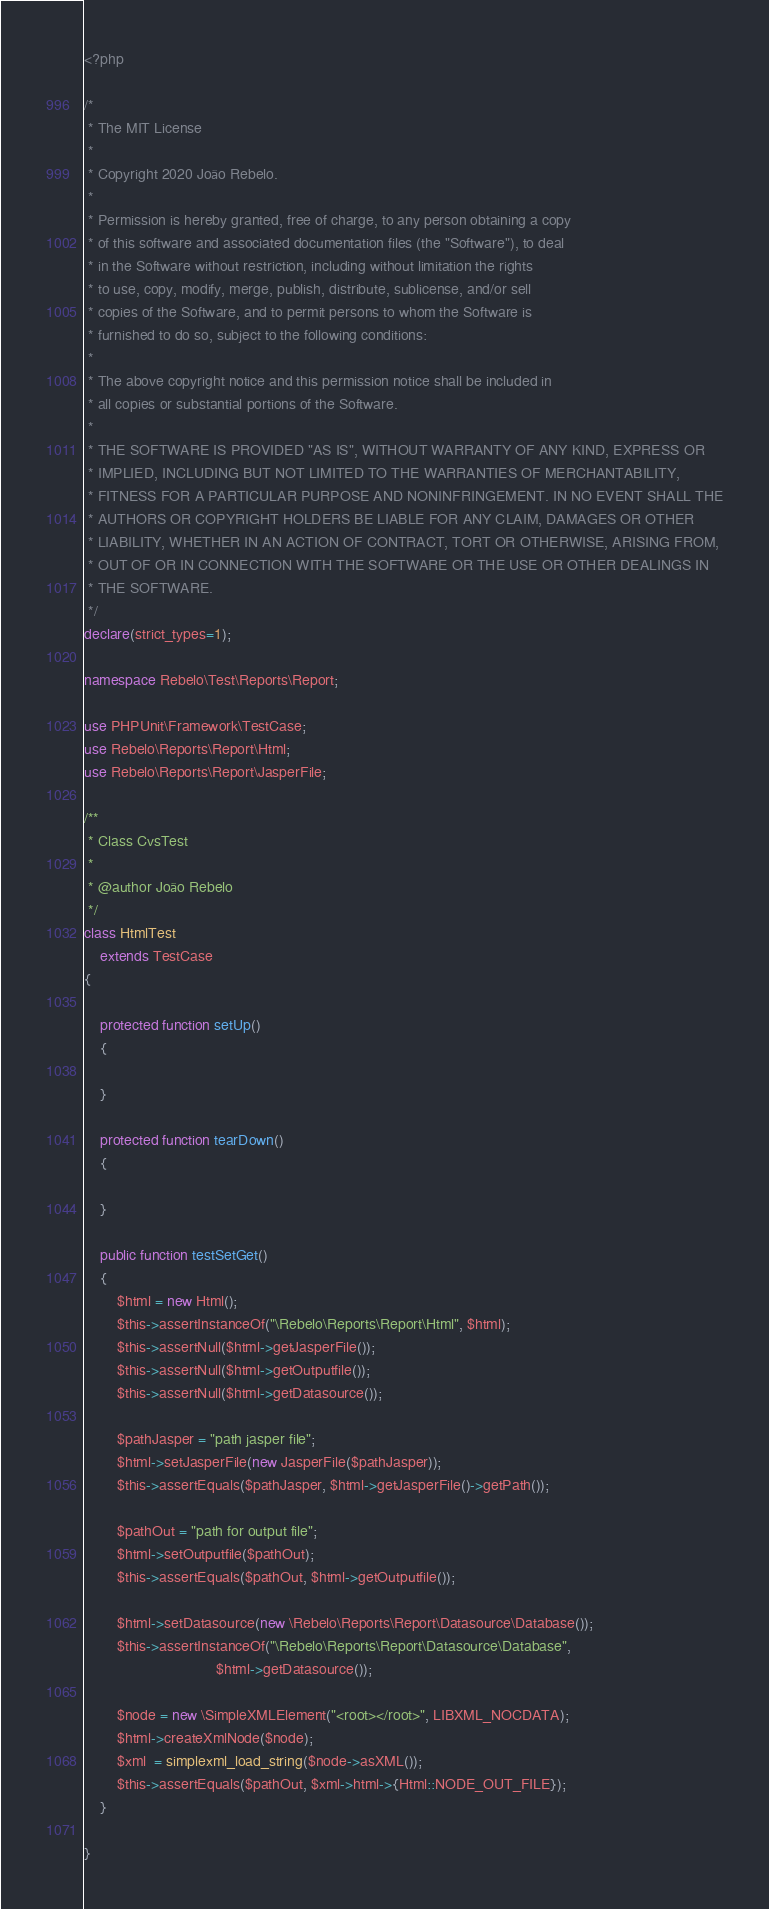<code> <loc_0><loc_0><loc_500><loc_500><_PHP_><?php

/*
 * The MIT License
 *
 * Copyright 2020 João Rebelo.
 *
 * Permission is hereby granted, free of charge, to any person obtaining a copy
 * of this software and associated documentation files (the "Software"), to deal
 * in the Software without restriction, including without limitation the rights
 * to use, copy, modify, merge, publish, distribute, sublicense, and/or sell
 * copies of the Software, and to permit persons to whom the Software is
 * furnished to do so, subject to the following conditions:
 *
 * The above copyright notice and this permission notice shall be included in
 * all copies or substantial portions of the Software.
 *
 * THE SOFTWARE IS PROVIDED "AS IS", WITHOUT WARRANTY OF ANY KIND, EXPRESS OR
 * IMPLIED, INCLUDING BUT NOT LIMITED TO THE WARRANTIES OF MERCHANTABILITY,
 * FITNESS FOR A PARTICULAR PURPOSE AND NONINFRINGEMENT. IN NO EVENT SHALL THE
 * AUTHORS OR COPYRIGHT HOLDERS BE LIABLE FOR ANY CLAIM, DAMAGES OR OTHER
 * LIABILITY, WHETHER IN AN ACTION OF CONTRACT, TORT OR OTHERWISE, ARISING FROM,
 * OUT OF OR IN CONNECTION WITH THE SOFTWARE OR THE USE OR OTHER DEALINGS IN
 * THE SOFTWARE.
 */
declare(strict_types=1);

namespace Rebelo\Test\Reports\Report;

use PHPUnit\Framework\TestCase;
use Rebelo\Reports\Report\Html;
use Rebelo\Reports\Report\JasperFile;

/**
 * Class CvsTest
 *
 * @author João Rebelo
 */
class HtmlTest
    extends TestCase
{

    protected function setUp()
    {

    }

    protected function tearDown()
    {

    }

    public function testSetGet()
    {
        $html = new Html();
        $this->assertInstanceOf("\Rebelo\Reports\Report\Html", $html);
        $this->assertNull($html->getJasperFile());
        $this->assertNull($html->getOutputfile());
        $this->assertNull($html->getDatasource());

        $pathJasper = "path jasper file";
        $html->setJasperFile(new JasperFile($pathJasper));
        $this->assertEquals($pathJasper, $html->getJasperFile()->getPath());

        $pathOut = "path for output file";
        $html->setOutputfile($pathOut);
        $this->assertEquals($pathOut, $html->getOutputfile());

        $html->setDatasource(new \Rebelo\Reports\Report\Datasource\Database());
        $this->assertInstanceOf("\Rebelo\Reports\Report\Datasource\Database",
                                $html->getDatasource());

        $node = new \SimpleXMLElement("<root></root>", LIBXML_NOCDATA);
        $html->createXmlNode($node);
        $xml  = simplexml_load_string($node->asXML());
        $this->assertEquals($pathOut, $xml->html->{Html::NODE_OUT_FILE});
    }

}
</code> 